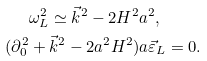<formula> <loc_0><loc_0><loc_500><loc_500>& \omega _ { L } ^ { 2 } \simeq \vec { k } ^ { 2 } - 2 H ^ { 2 } a ^ { 2 } , \\ ( \partial _ { 0 } ^ { 2 } & + \vec { k } ^ { 2 } - 2 a ^ { 2 } H ^ { 2 } ) a \vec { \varepsilon } _ { L } = 0 .</formula> 